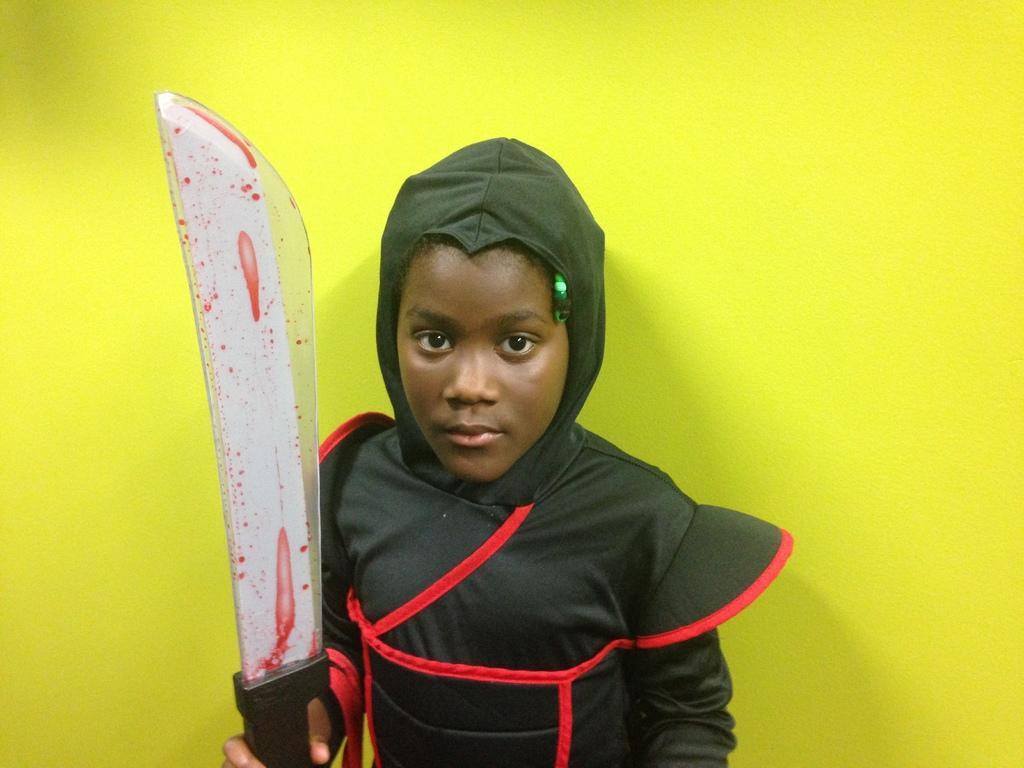Please provide a concise description of this image. In this image there is a kid wearing costume and holding a sword in his hand, in the background there is a wall. 